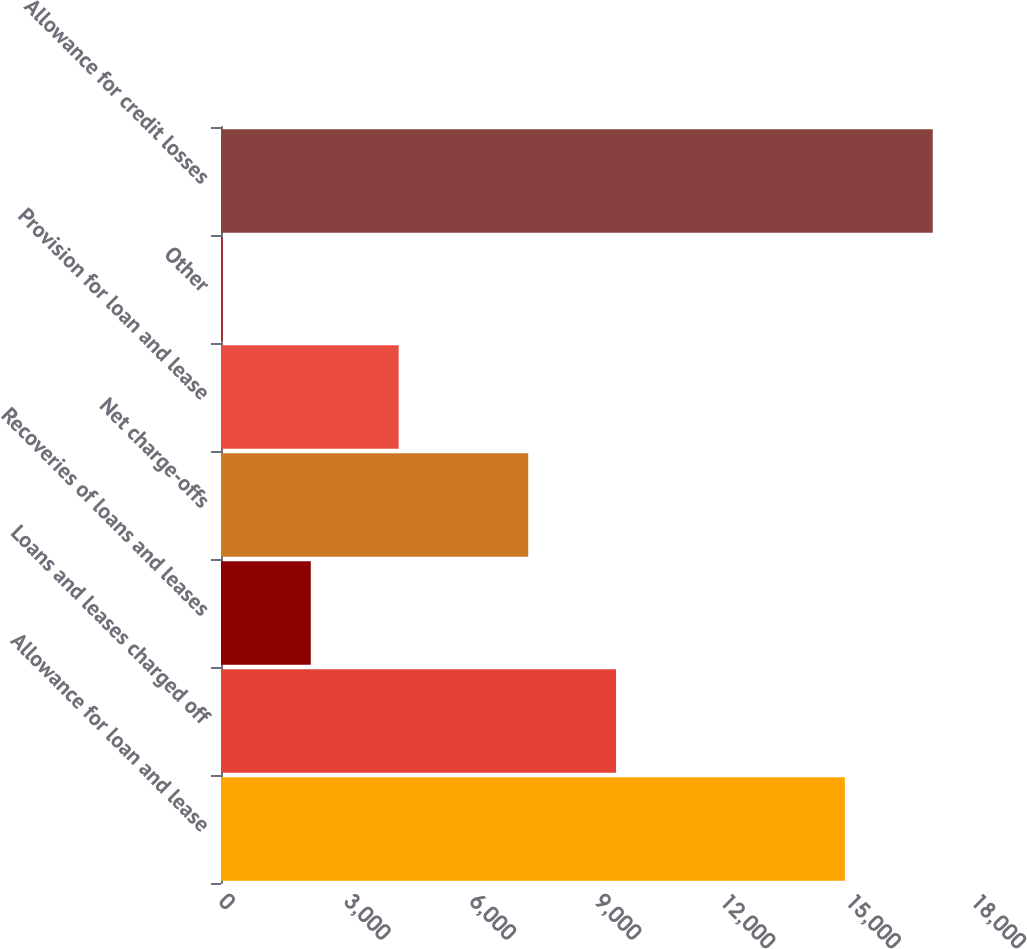Convert chart to OTSL. <chart><loc_0><loc_0><loc_500><loc_500><bar_chart><fcel>Allowance for loan and lease<fcel>Loans and leases charged off<fcel>Recoveries of loans and leases<fcel>Net charge-offs<fcel>Provision for loan and lease<fcel>Other<fcel>Allowance for credit losses<nl><fcel>14933<fcel>9456.3<fcel>2149.3<fcel>7353<fcel>4252.6<fcel>46<fcel>17036.3<nl></chart> 